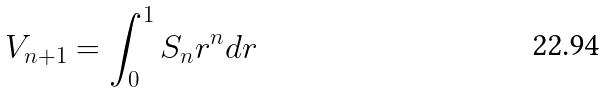Convert formula to latex. <formula><loc_0><loc_0><loc_500><loc_500>V _ { n + 1 } = \int _ { 0 } ^ { 1 } S _ { n } r ^ { n } d r</formula> 